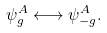Convert formula to latex. <formula><loc_0><loc_0><loc_500><loc_500>\psi ^ { A } _ { g } \longleftrightarrow \psi ^ { A } _ { - g } .</formula> 